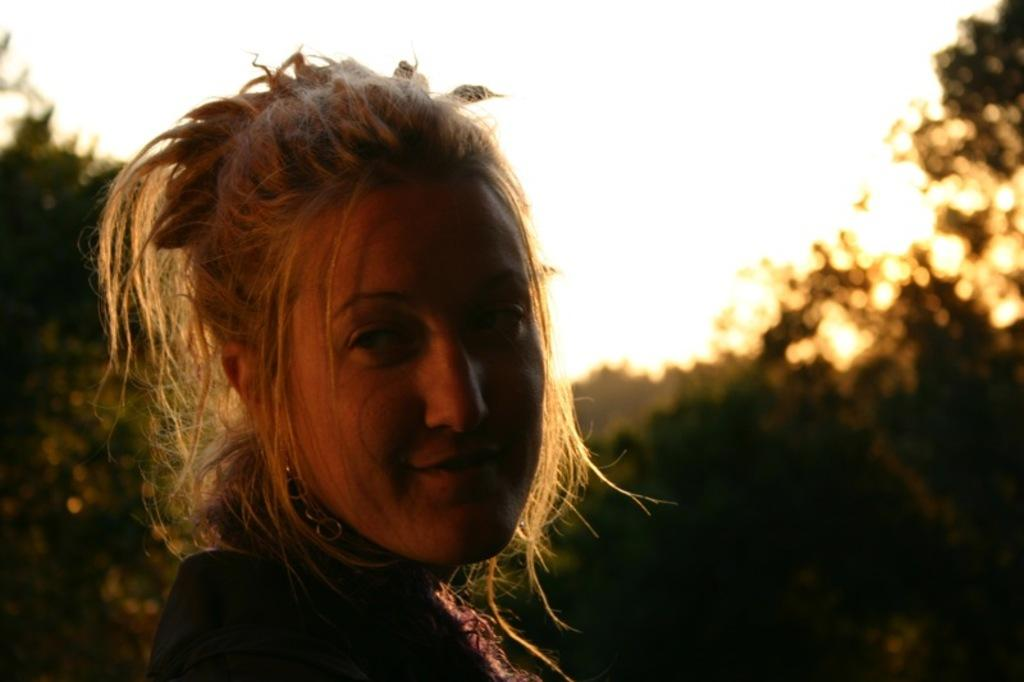Who is present in the image? There is a woman in the image. What is the woman's facial expression? The woman is smiling. What can be seen in the background of the image? There are trees and the sky visible in the background of the image. What type of machine is the woman using in the image? There is no machine present in the image; it features a woman smiling with trees and the sky visible in the background. 